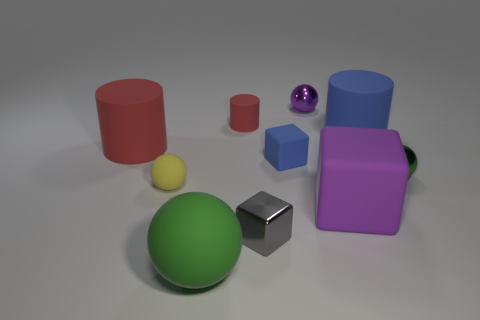Are there any small yellow balls behind the red cylinder behind the big matte thing left of the yellow object?
Make the answer very short. No. What is the size of the matte thing that is both to the right of the big green matte ball and left of the gray block?
Your response must be concise. Small. What number of large cylinders have the same material as the tiny gray thing?
Provide a succinct answer. 0. What number of spheres are either small yellow matte things or large green matte objects?
Offer a very short reply. 2. There is a green sphere that is in front of the tiny block that is in front of the green object right of the small red matte cylinder; what is its size?
Provide a succinct answer. Large. There is a metal object that is on the left side of the big blue cylinder and on the right side of the small gray block; what color is it?
Give a very brief answer. Purple. There is a purple ball; does it have the same size as the red rubber cylinder on the left side of the small red cylinder?
Ensure brevity in your answer.  No. What is the color of the tiny thing that is the same shape as the large blue thing?
Offer a very short reply. Red. Is the yellow ball the same size as the green shiny ball?
Ensure brevity in your answer.  Yes. What number of other objects are the same size as the blue matte cylinder?
Keep it short and to the point. 3. 